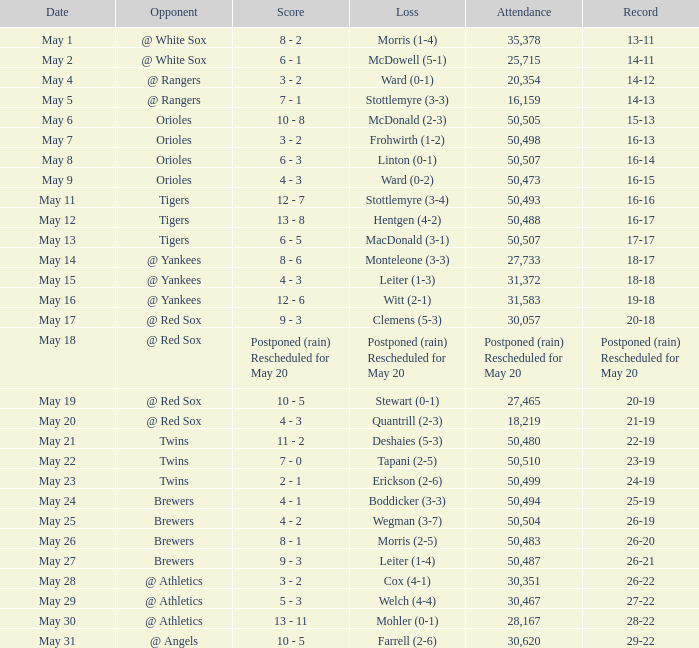On what date was their record 26-19? May 25. 